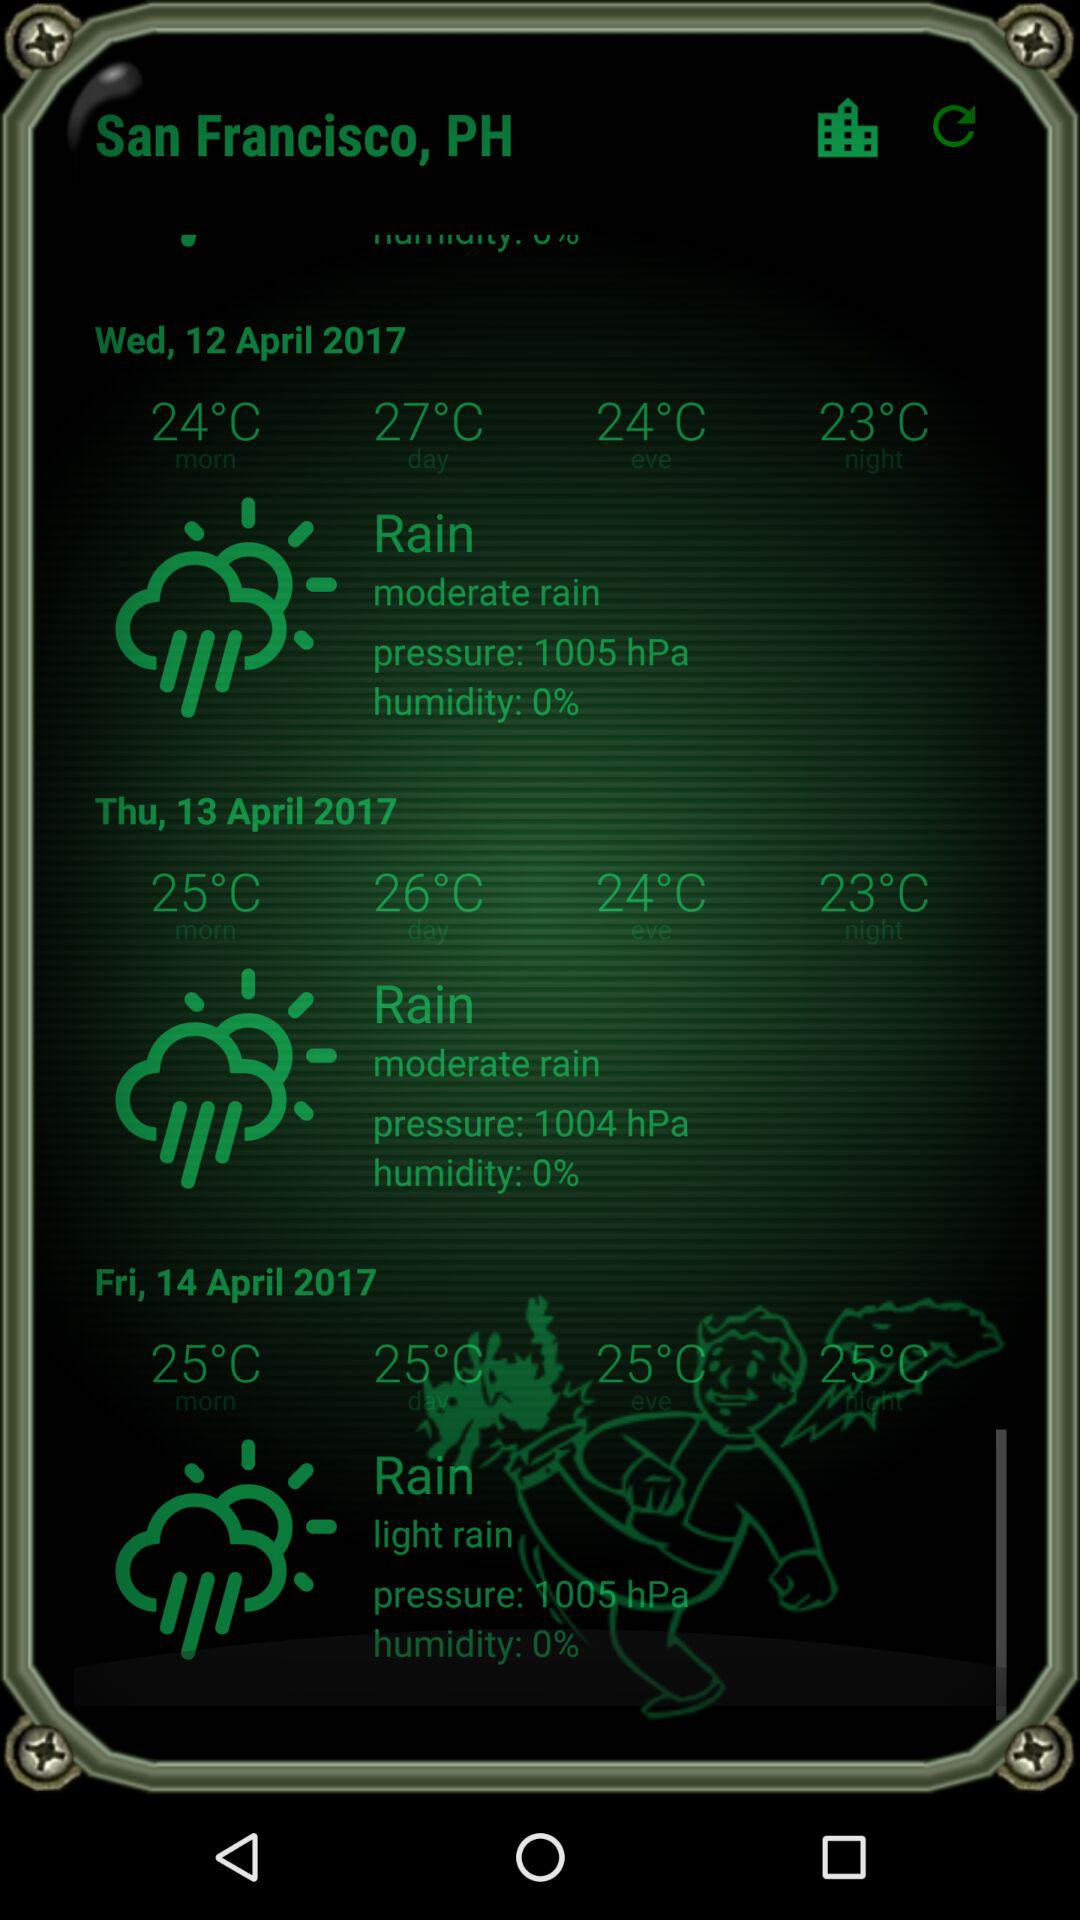What is the temperature on Thursday night? The temperature is 23 °C. 